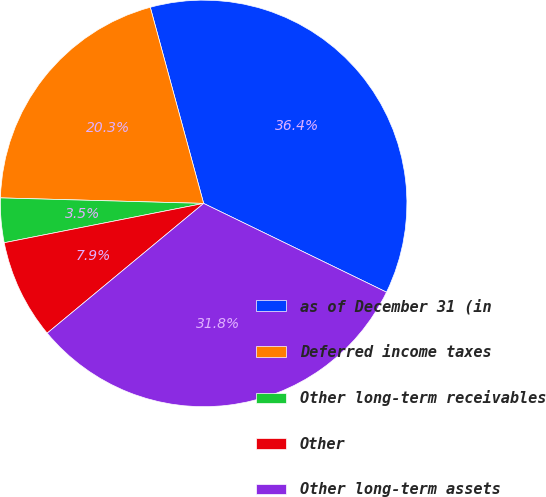Convert chart. <chart><loc_0><loc_0><loc_500><loc_500><pie_chart><fcel>as of December 31 (in<fcel>Deferred income taxes<fcel>Other long-term receivables<fcel>Other<fcel>Other long-term assets<nl><fcel>36.42%<fcel>20.34%<fcel>3.53%<fcel>7.92%<fcel>31.79%<nl></chart> 